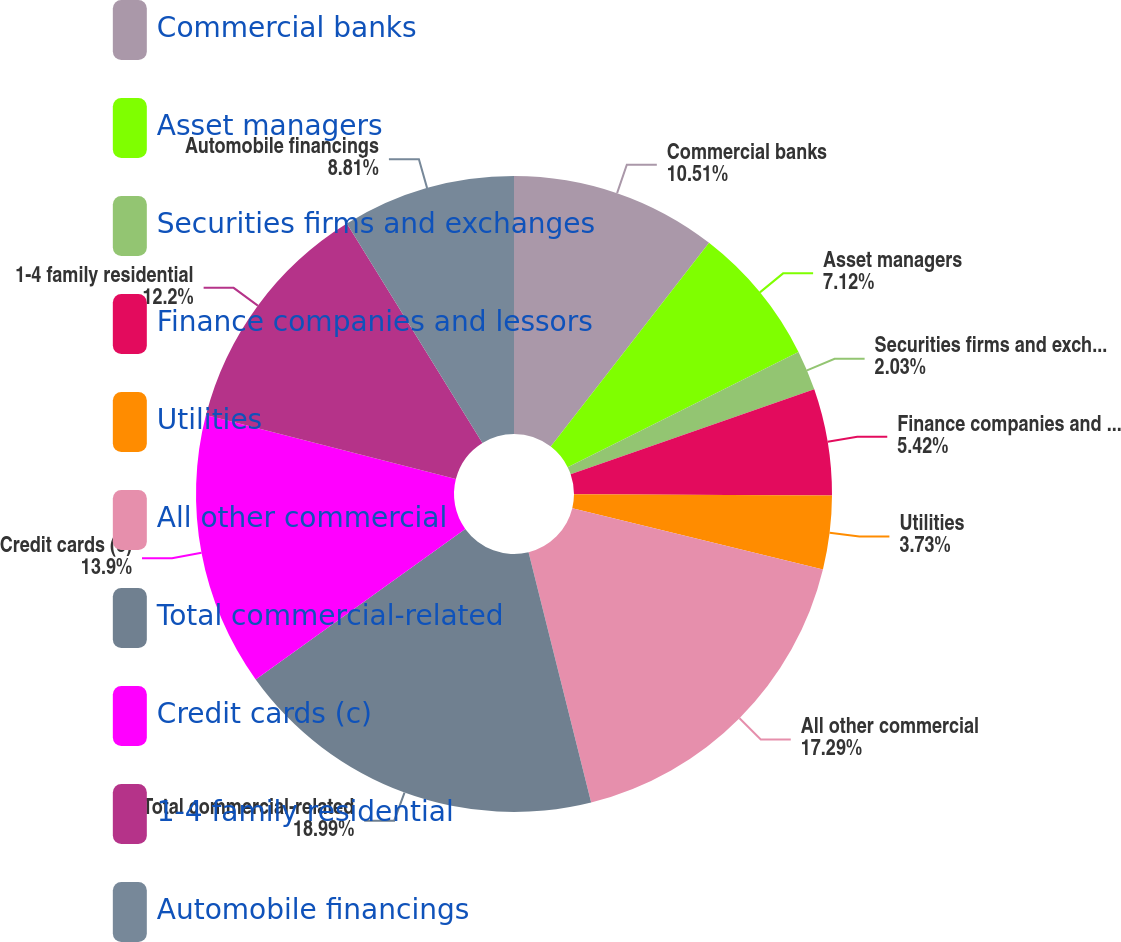<chart> <loc_0><loc_0><loc_500><loc_500><pie_chart><fcel>Commercial banks<fcel>Asset managers<fcel>Securities firms and exchanges<fcel>Finance companies and lessors<fcel>Utilities<fcel>All other commercial<fcel>Total commercial-related<fcel>Credit cards (c)<fcel>1-4 family residential<fcel>Automobile financings<nl><fcel>10.51%<fcel>7.12%<fcel>2.03%<fcel>5.42%<fcel>3.73%<fcel>17.29%<fcel>18.99%<fcel>13.9%<fcel>12.2%<fcel>8.81%<nl></chart> 